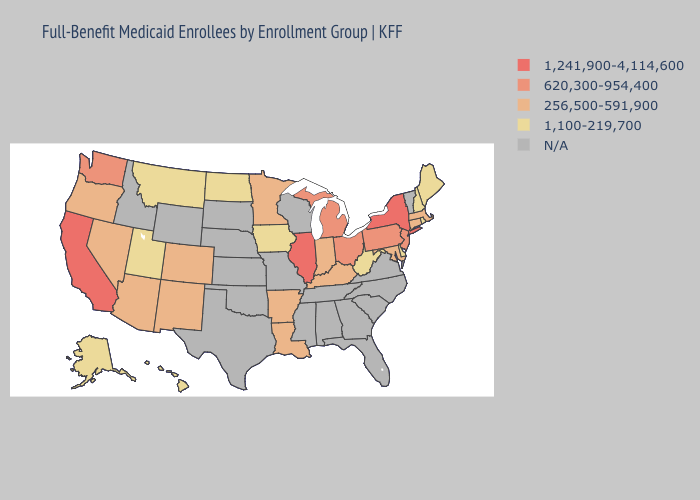Name the states that have a value in the range 256,500-591,900?
Give a very brief answer. Arizona, Arkansas, Colorado, Connecticut, Indiana, Kentucky, Louisiana, Maryland, Massachusetts, Minnesota, Nevada, New Mexico, Oregon. What is the value of Louisiana?
Keep it brief. 256,500-591,900. What is the highest value in the USA?
Quick response, please. 1,241,900-4,114,600. Does the first symbol in the legend represent the smallest category?
Write a very short answer. No. Which states hav the highest value in the MidWest?
Be succinct. Illinois. Does Illinois have the lowest value in the USA?
Short answer required. No. Name the states that have a value in the range 620,300-954,400?
Write a very short answer. Michigan, New Jersey, Ohio, Pennsylvania, Washington. How many symbols are there in the legend?
Be succinct. 5. What is the lowest value in the USA?
Answer briefly. 1,100-219,700. What is the lowest value in states that border New Hampshire?
Write a very short answer. 1,100-219,700. Is the legend a continuous bar?
Write a very short answer. No. 